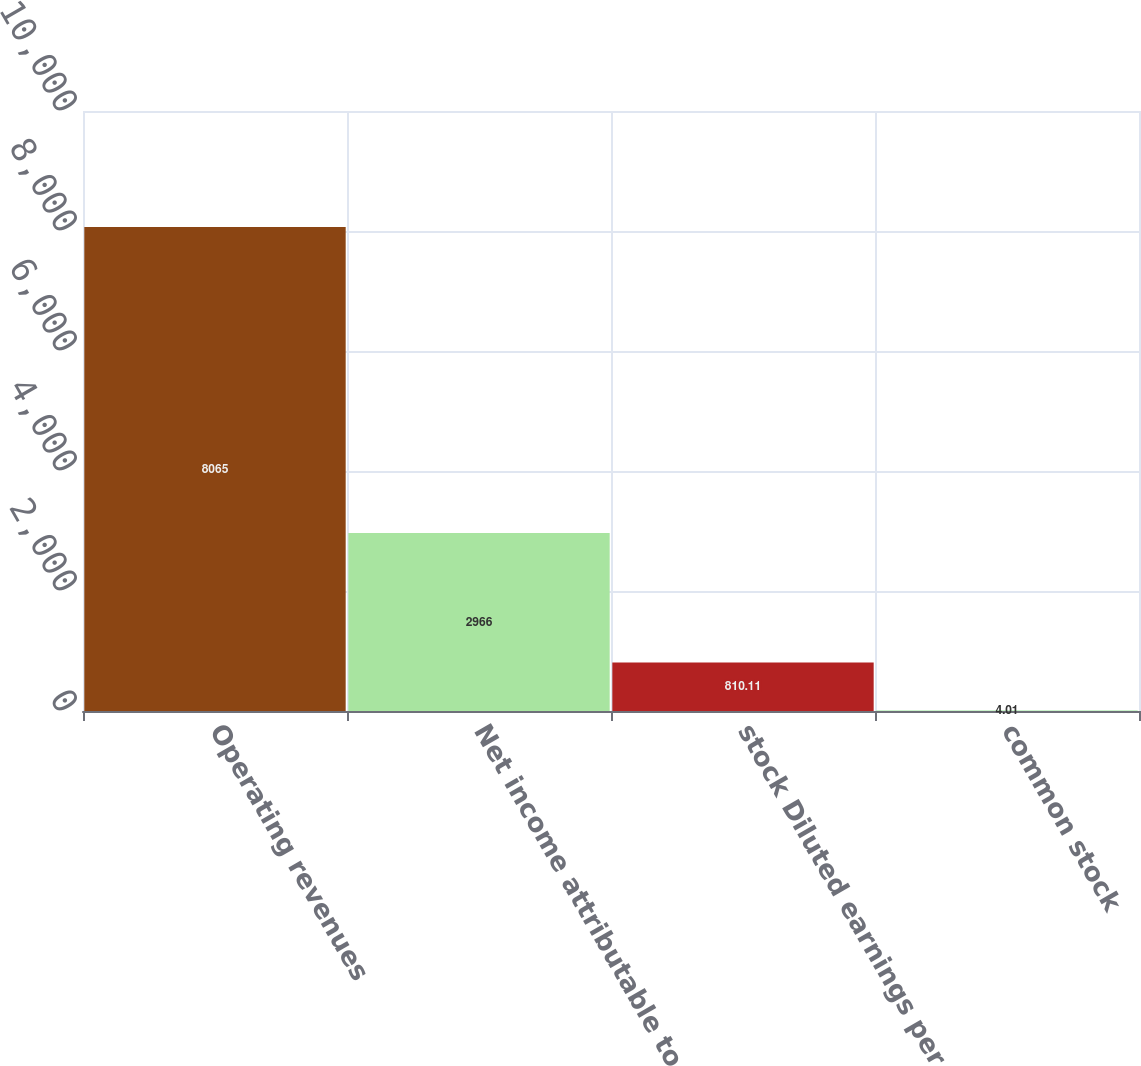<chart> <loc_0><loc_0><loc_500><loc_500><bar_chart><fcel>Operating revenues<fcel>Net income attributable to<fcel>stock Diluted earnings per<fcel>common stock<nl><fcel>8065<fcel>2966<fcel>810.11<fcel>4.01<nl></chart> 